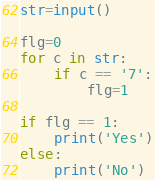Convert code to text. <code><loc_0><loc_0><loc_500><loc_500><_Python_>str=input()

flg=0
for c in str:
    if c == '7':
        flg=1

if flg == 1:
    print('Yes')
else:
    print('No')
</code> 